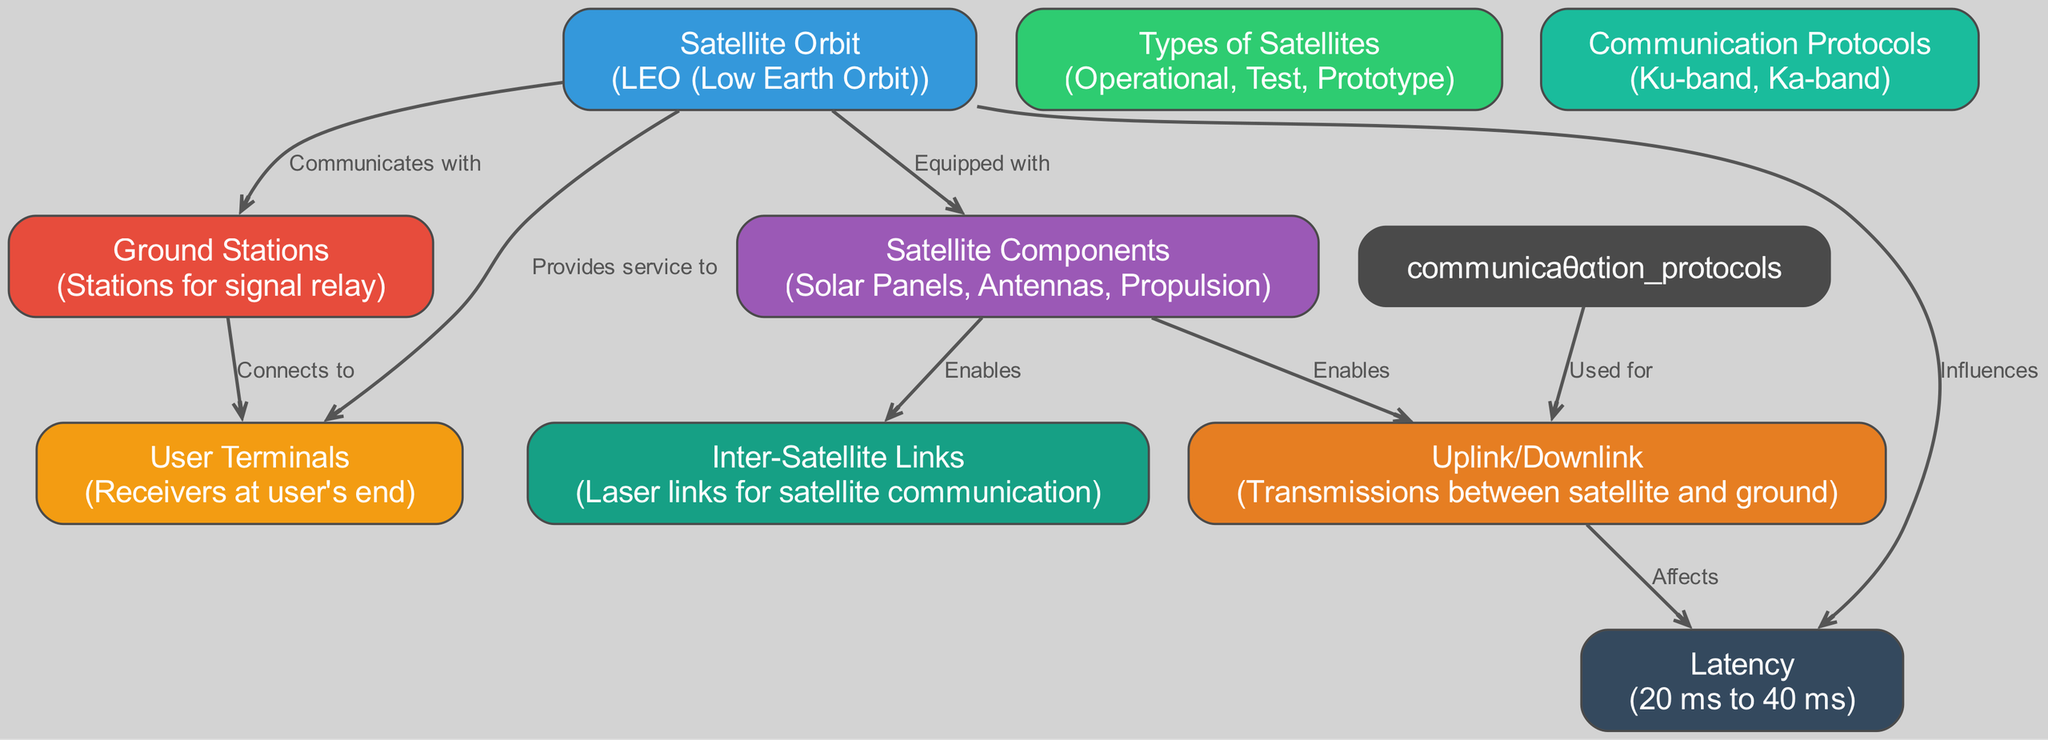How many types of satellites are in the diamond? The diagram lists three types of satellites, which are directly mentioned under the "Types of Satellites" node.
Answer: 3 What influences latency in this constellation? The diagram specifies that "Satellite Orbit" influences "Latency," indicating a direct impact relationship shown in the edge connecting these nodes.
Answer: Satellite Orbit What enables uplink/downlink communication? The "Satellite Components" node directly enables "Uplink/Downlink," according to the edge connecting these two nodes.
Answer: Satellite Components Which protocols are used for uplink/downlink? The "Communication Protocols" node is explicitly connected to "Uplink/Downlink," indicating these protocols are utilized for communication between ground stations and satellites.
Answer: Ku-band, Ka-band What connects ground stations with user terminals? The diagram shows a direct link from "Ground Stations" to "User Terminals," demonstrating that ground stations serve to connect with user terminals for service.
Answer: Connects to What component enables inter-satellite links for communication? The "Satellite Components" are responsible for enabling "Inter-Satellite Links" as depicted in the edge between these two nodes, highlighting their function in the satellite network.
Answer: Satellite Components What type of orbit is used by Starlink satellites? The diagram clearly categorizes the "Satellite Orbit" as "LEO (Low Earth Orbit)," providing a specific definition of the orbit type utilized.
Answer: LEO (Low Earth Orbit) What is the latency range indicated in the diagram? The "Latency" node conveys that the expected latency for the Starlink system ranges from 20 ms to 40 ms, clearly specified as part of its description.
Answer: 20 ms to 40 ms 